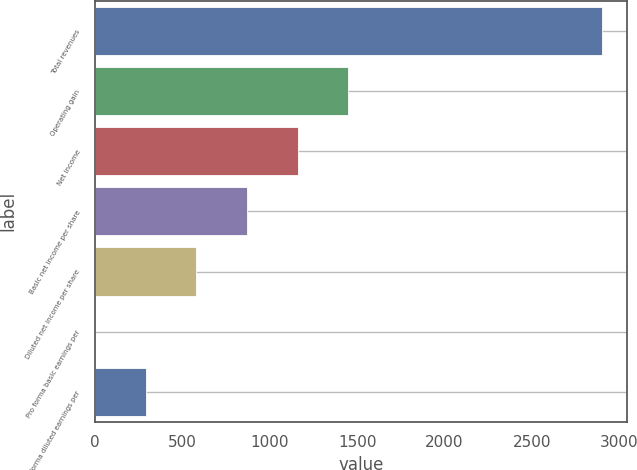Convert chart. <chart><loc_0><loc_0><loc_500><loc_500><bar_chart><fcel>Total revenues<fcel>Operating gain<fcel>Net income<fcel>Basic net income per share<fcel>Diluted net income per share<fcel>Pro forma basic earnings per<fcel>Pro forma diluted earnings per<nl><fcel>2900.1<fcel>1450.4<fcel>1160.46<fcel>870.52<fcel>580.58<fcel>0.7<fcel>290.64<nl></chart> 